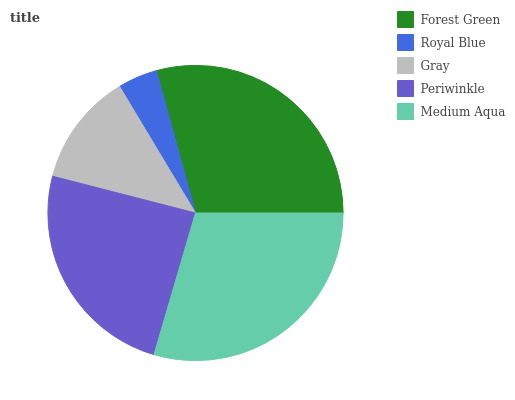Is Royal Blue the minimum?
Answer yes or no. Yes. Is Medium Aqua the maximum?
Answer yes or no. Yes. Is Gray the minimum?
Answer yes or no. No. Is Gray the maximum?
Answer yes or no. No. Is Gray greater than Royal Blue?
Answer yes or no. Yes. Is Royal Blue less than Gray?
Answer yes or no. Yes. Is Royal Blue greater than Gray?
Answer yes or no. No. Is Gray less than Royal Blue?
Answer yes or no. No. Is Periwinkle the high median?
Answer yes or no. Yes. Is Periwinkle the low median?
Answer yes or no. Yes. Is Gray the high median?
Answer yes or no. No. Is Medium Aqua the low median?
Answer yes or no. No. 